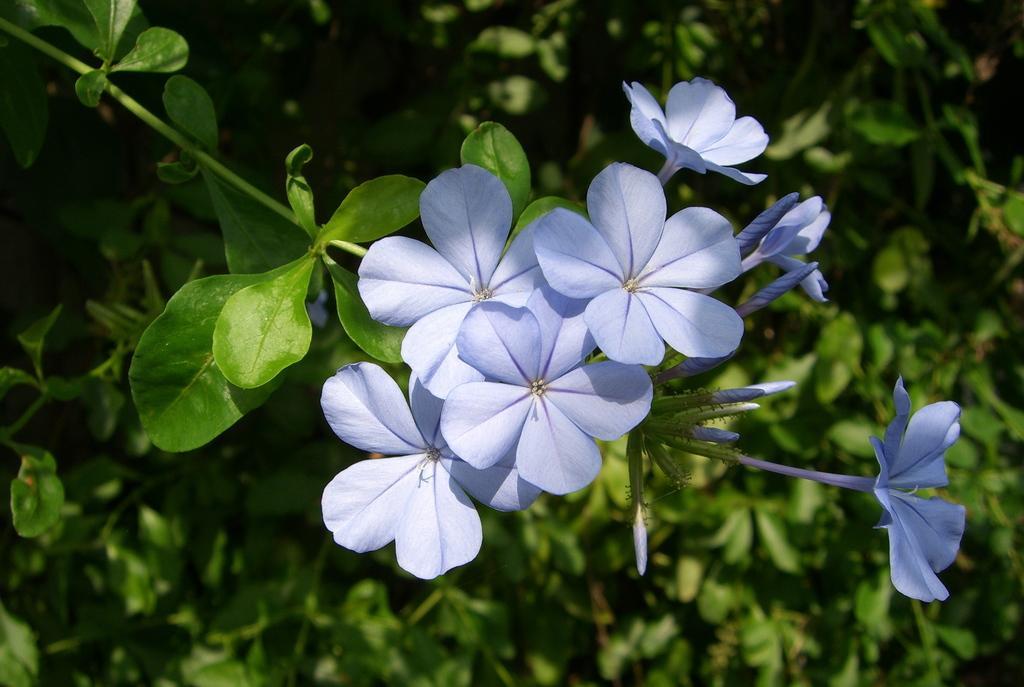In one or two sentences, can you explain what this image depicts? There are violet color flowers on the stem. In the background it is green and blurred. 